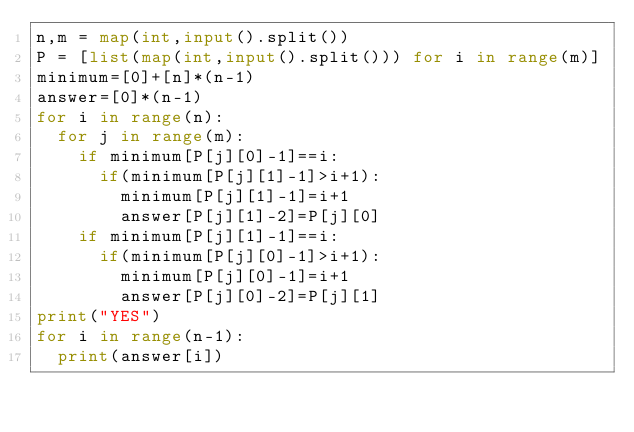Convert code to text. <code><loc_0><loc_0><loc_500><loc_500><_Python_>n,m = map(int,input().split())
P = [list(map(int,input().split())) for i in range(m)]
minimum=[0]+[n]*(n-1)
answer=[0]*(n-1)
for i in range(n):
  for j in range(m):
    if minimum[P[j][0]-1]==i:
      if(minimum[P[j][1]-1]>i+1):
        minimum[P[j][1]-1]=i+1
        answer[P[j][1]-2]=P[j][0]
    if minimum[P[j][1]-1]==i:
      if(minimum[P[j][0]-1]>i+1):
        minimum[P[j][0]-1]=i+1
        answer[P[j][0]-2]=P[j][1]
print("YES")
for i in range(n-1):
  print(answer[i])</code> 